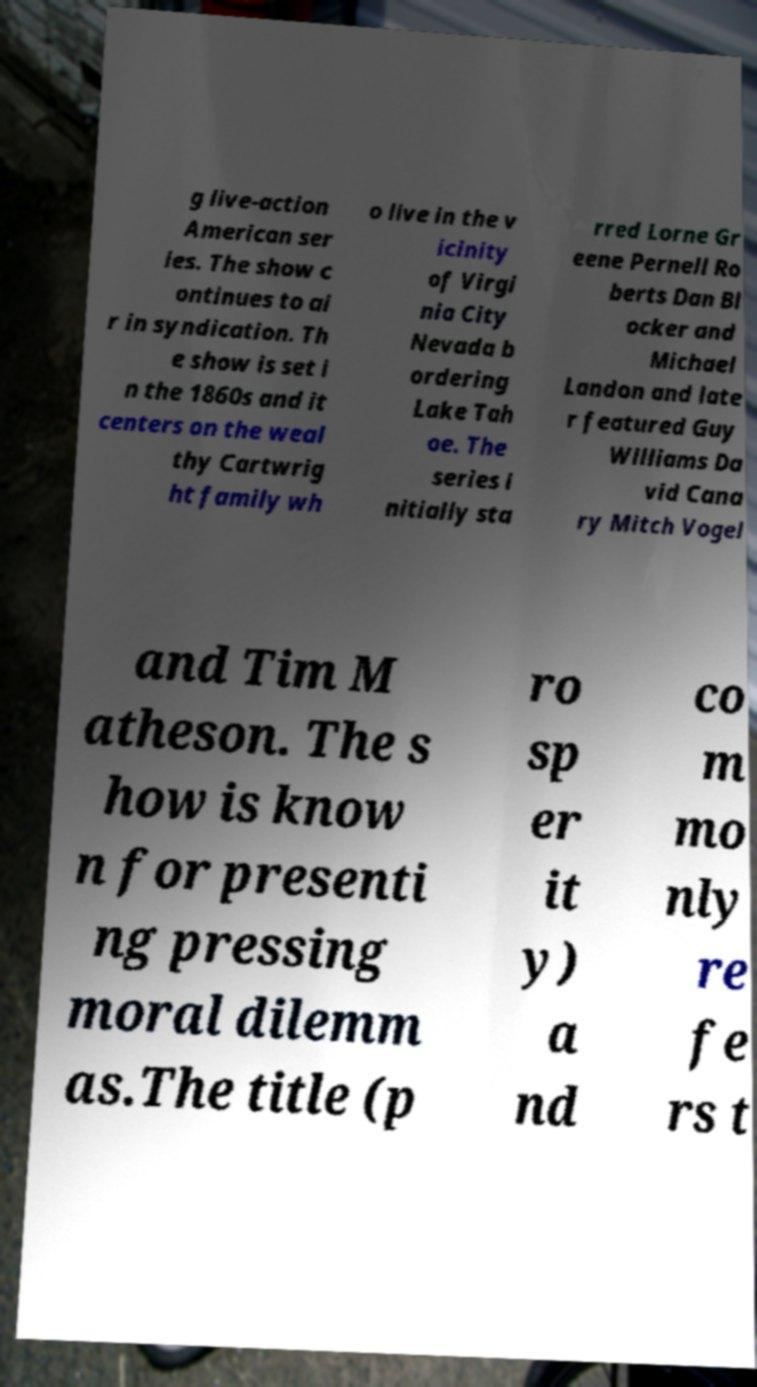What messages or text are displayed in this image? I need them in a readable, typed format. g live-action American ser ies. The show c ontinues to ai r in syndication. Th e show is set i n the 1860s and it centers on the weal thy Cartwrig ht family wh o live in the v icinity of Virgi nia City Nevada b ordering Lake Tah oe. The series i nitially sta rred Lorne Gr eene Pernell Ro berts Dan Bl ocker and Michael Landon and late r featured Guy Williams Da vid Cana ry Mitch Vogel and Tim M atheson. The s how is know n for presenti ng pressing moral dilemm as.The title (p ro sp er it y) a nd co m mo nly re fe rs t 